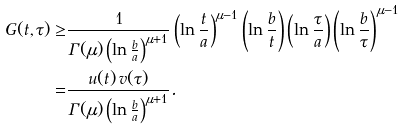Convert formula to latex. <formula><loc_0><loc_0><loc_500><loc_500>G ( t , \tau ) \geq & \frac { 1 } { \Gamma ( \mu ) \left ( \ln \frac { b } { a } \right ) ^ { \mu + 1 } } \left ( \ln \frac { t } { a } \right ) ^ { \mu - 1 } \left ( \ln \frac { b } { t } \right ) \left ( \ln \frac { \tau } { a } \right ) \left ( \ln \frac { b } { \tau } \right ) ^ { \mu - 1 } \\ = & \frac { u ( t ) \, v ( \tau ) } { \Gamma ( \mu ) \left ( \ln \frac { b } { a } \right ) ^ { \mu + 1 } } .</formula> 